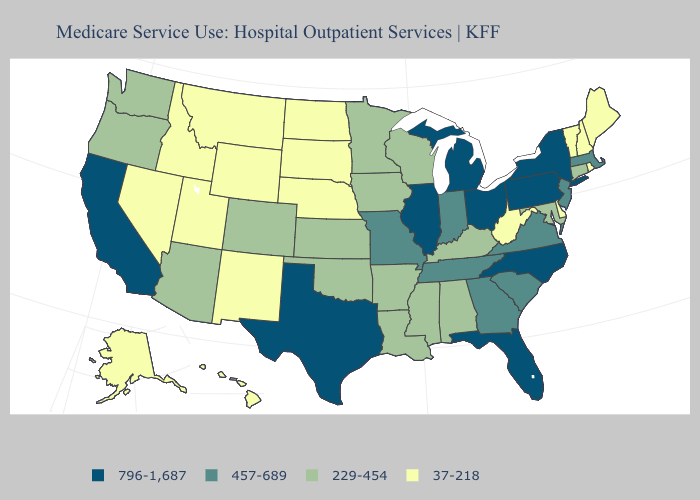What is the value of Massachusetts?
Write a very short answer. 457-689. What is the highest value in states that border South Dakota?
Answer briefly. 229-454. Which states have the lowest value in the USA?
Give a very brief answer. Alaska, Delaware, Hawaii, Idaho, Maine, Montana, Nebraska, Nevada, New Hampshire, New Mexico, North Dakota, Rhode Island, South Dakota, Utah, Vermont, West Virginia, Wyoming. What is the highest value in the USA?
Answer briefly. 796-1,687. Name the states that have a value in the range 37-218?
Be succinct. Alaska, Delaware, Hawaii, Idaho, Maine, Montana, Nebraska, Nevada, New Hampshire, New Mexico, North Dakota, Rhode Island, South Dakota, Utah, Vermont, West Virginia, Wyoming. Among the states that border North Dakota , which have the highest value?
Keep it brief. Minnesota. What is the value of California?
Be succinct. 796-1,687. Is the legend a continuous bar?
Be succinct. No. Name the states that have a value in the range 229-454?
Be succinct. Alabama, Arizona, Arkansas, Colorado, Connecticut, Iowa, Kansas, Kentucky, Louisiana, Maryland, Minnesota, Mississippi, Oklahoma, Oregon, Washington, Wisconsin. What is the highest value in states that border Alabama?
Answer briefly. 796-1,687. Which states have the highest value in the USA?
Concise answer only. California, Florida, Illinois, Michigan, New York, North Carolina, Ohio, Pennsylvania, Texas. Name the states that have a value in the range 229-454?
Short answer required. Alabama, Arizona, Arkansas, Colorado, Connecticut, Iowa, Kansas, Kentucky, Louisiana, Maryland, Minnesota, Mississippi, Oklahoma, Oregon, Washington, Wisconsin. Among the states that border Texas , does New Mexico have the lowest value?
Answer briefly. Yes. How many symbols are there in the legend?
Concise answer only. 4. Does Pennsylvania have the lowest value in the USA?
Give a very brief answer. No. 